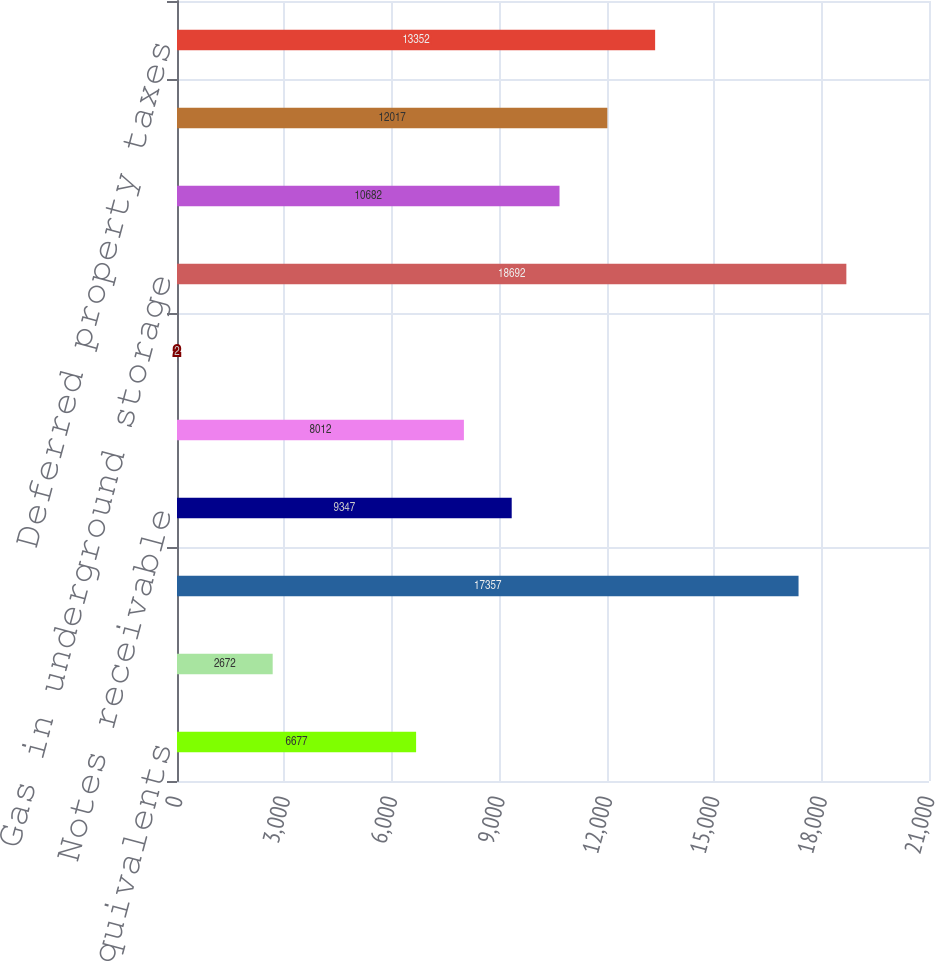<chart> <loc_0><loc_0><loc_500><loc_500><bar_chart><fcel>Cash and cash equivalents<fcel>Restricted cash and cash<fcel>less allowances of 21 in 2009<fcel>Notes receivable<fcel>Accrued power supply and gas<fcel>Accounts receivable - related<fcel>Gas in underground storage<fcel>Materials and supplies<fcel>Generating plant fuel stock<fcel>Deferred property taxes<nl><fcel>6677<fcel>2672<fcel>17357<fcel>9347<fcel>8012<fcel>2<fcel>18692<fcel>10682<fcel>12017<fcel>13352<nl></chart> 